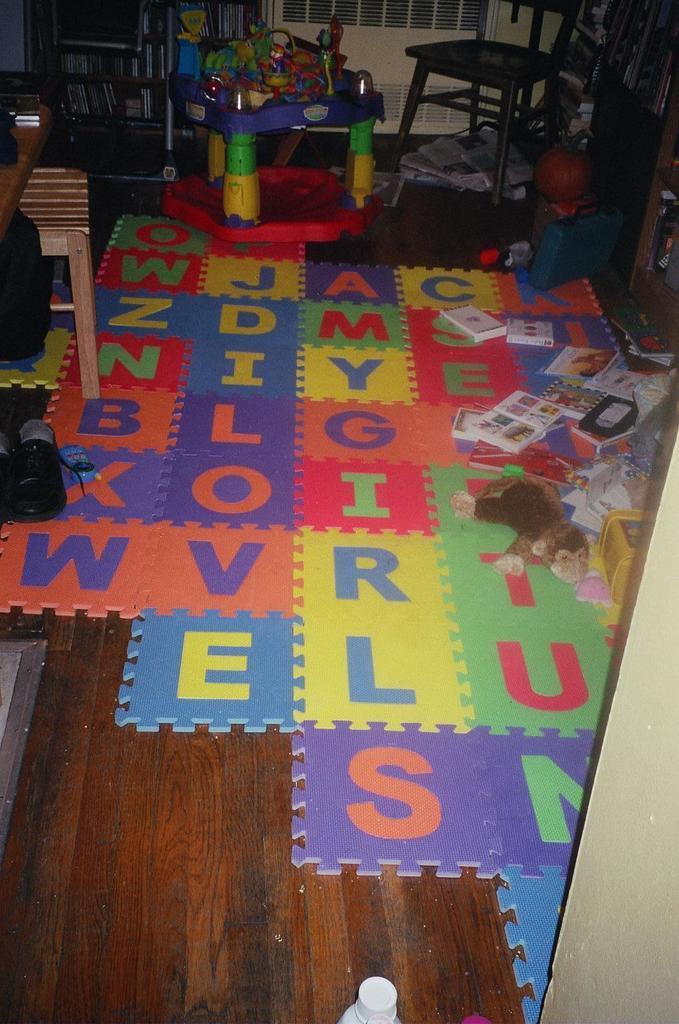In one or two sentences, can you explain what this image depicts? In this image, we can see a chair, stool, some papers, books, racks, toys, puzzle pieces and some other objects. At the bottom, there is a floor. 